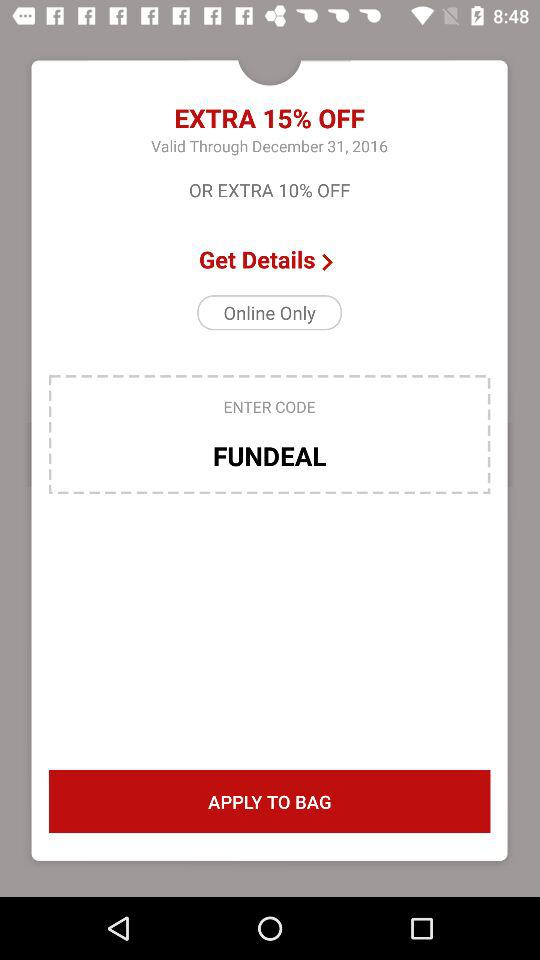How much percent discount are available?
When the provided information is insufficient, respond with <no answer>. <no answer> 